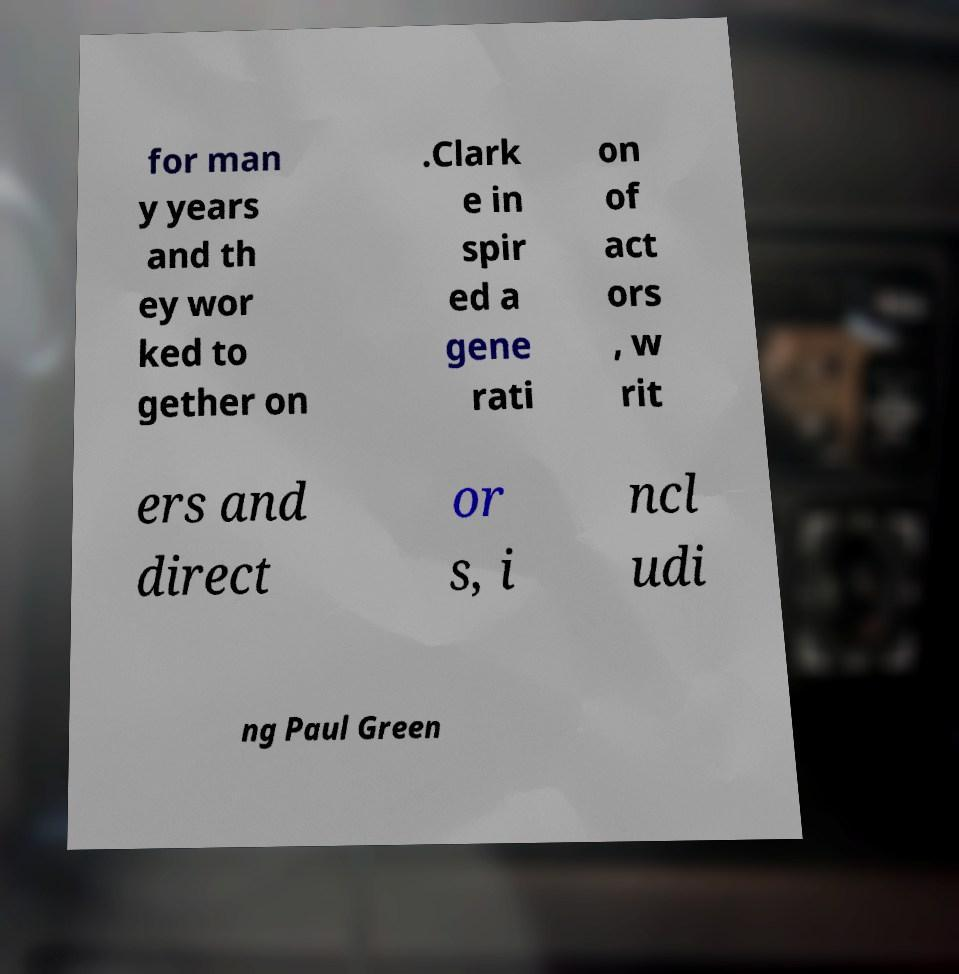There's text embedded in this image that I need extracted. Can you transcribe it verbatim? for man y years and th ey wor ked to gether on .Clark e in spir ed a gene rati on of act ors , w rit ers and direct or s, i ncl udi ng Paul Green 